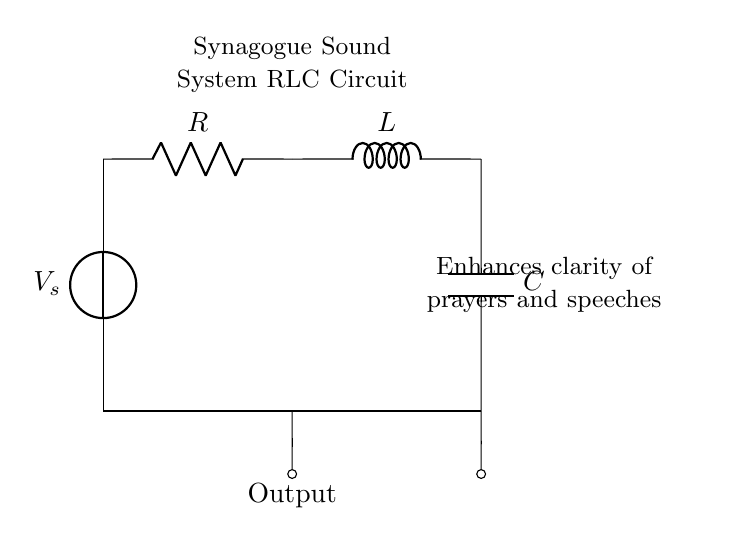What are the components in this circuit? The circuit contains a voltage source, a resistor, an inductor, and a capacitor. Each component is represented in the diagram, with specific labels indicating their roles.
Answer: voltage source, resistor, inductor, capacitor What is the purpose of this RLC circuit? The purpose, as indicated in the diagram, is to enhance the clarity of prayers and speeches in a synagogue sound system. This is reflected in the label included in the diagram.
Answer: enhance clarity of prayers and speeches How many components are in this circuit? To determine this, count each distinct component labeled in the circuit: the voltage source, resistor, inductor, and capacitor. There are four in total.
Answer: four What is connected to the output? The output is connected to the node from the resistor, which transmits the signal enhanced by the RLC circuit. This is indicated by the short wire leading to the output label.
Answer: resistor What happens to the signal in this RLC circuit? In an RLC circuit, the signal can be influenced by the properties of the resistor, inductor, and capacitor, affecting the amplitude and phase of the output signal. This interaction primarily involves resonance between these components.
Answer: affected by RLC properties What is the position of the capacitor in this circuit? The capacitor is located at the end of the circuit diagram, connected to the inductor. It connects to the ground, completing the circuit. This is identifiable both by its label and position in the layout.
Answer: connected to ground Which component is directly connected to the voltage source? The resistor is directly connected to the voltage source in this circuit. This is shown by the line extending from the voltage source to the resistor, indicating a direct connection.
Answer: resistor 